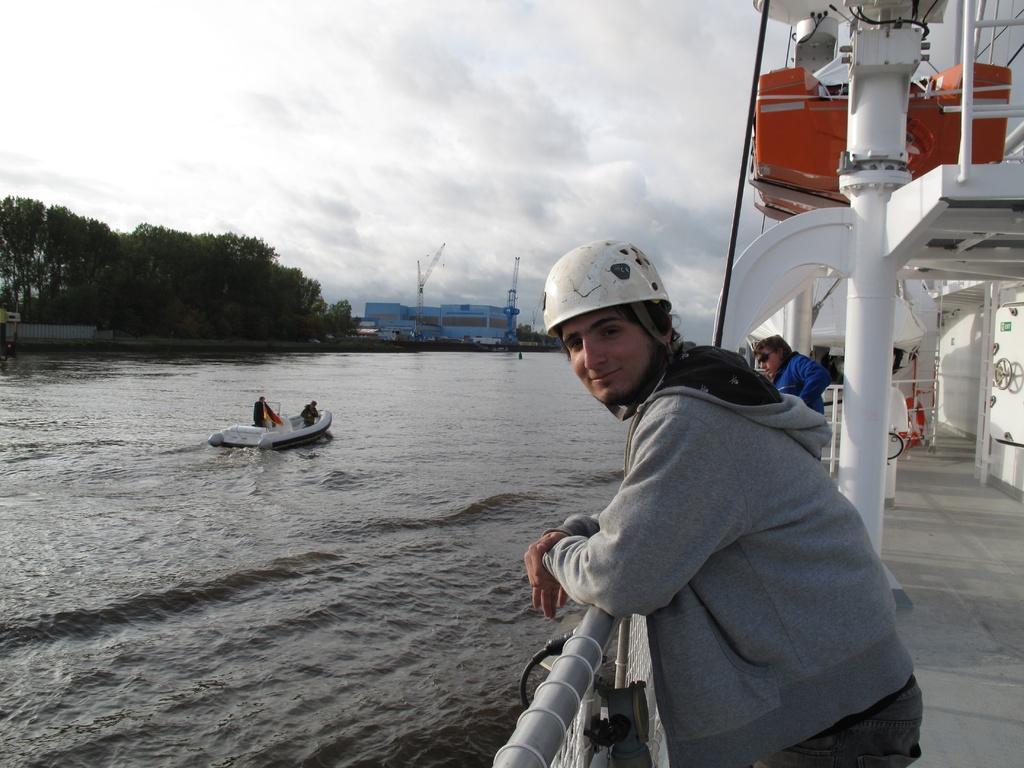Please provide a concise description of this image. Here in this picture we can see a person standing in a ship, which is present in a river over there, as we can see water present all over there and we can see other people also standing in the ship and in the water we can see another boat present with a couple of people in it and the person in the front is wearing helmet on him and in the far we can see buildings present and we can see trees and plants all over there and we can see clouds in the sky. 